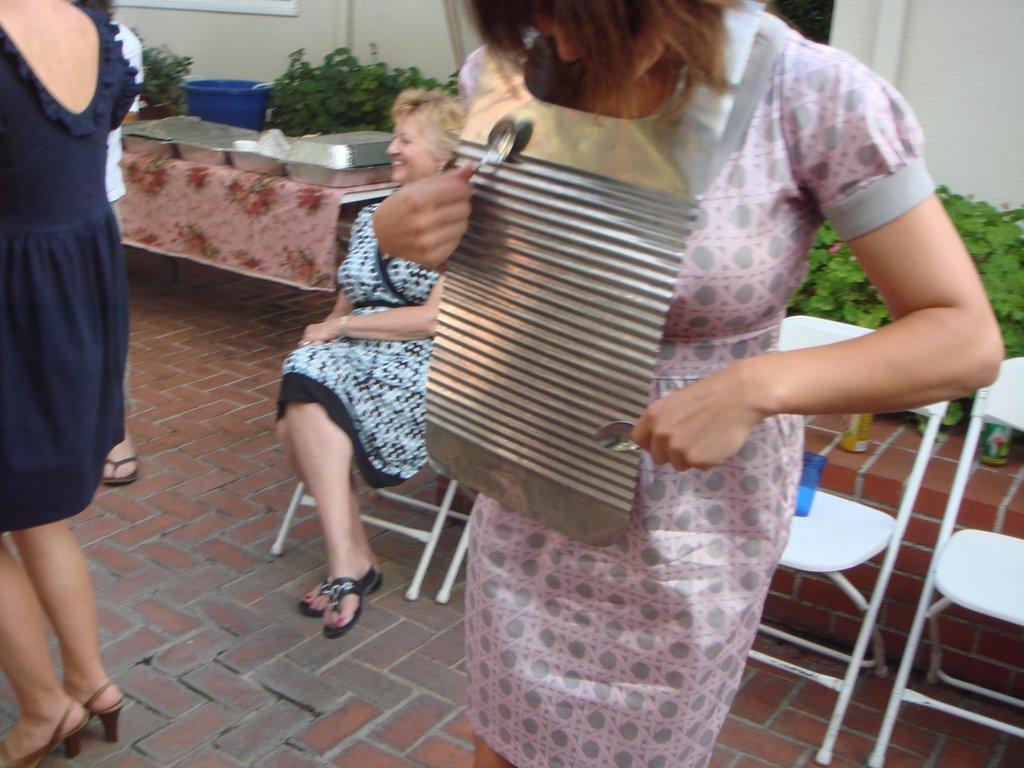Could you give a brief overview of what you see in this image? On the left side, there is a woman in a dress, standing on a floor. On the right side, there is a woman in a pink color dress, holding spoons with both hands and standing. In the background, there is another woman sitting on a chair, there is a person standing, there are plants and there is a building which is having white wall. 